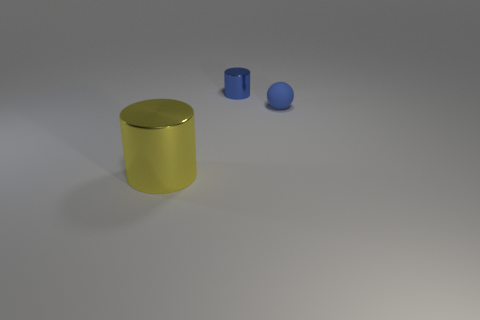Does the tiny blue thing behind the blue sphere have the same material as the cylinder in front of the tiny blue matte ball?
Provide a short and direct response. Yes. The yellow shiny thing has what size?
Keep it short and to the point. Large. There is a yellow object that is the same shape as the blue shiny thing; what size is it?
Your answer should be very brief. Large. What number of shiny objects are in front of the tiny blue cylinder?
Make the answer very short. 1. There is a object left of the metal cylinder behind the large shiny cylinder; what color is it?
Offer a very short reply. Yellow. Is there anything else that has the same shape as the small blue matte thing?
Make the answer very short. No. Are there an equal number of things right of the tiny blue cylinder and small matte objects on the right side of the yellow thing?
Offer a terse response. Yes. How many balls are large purple matte objects or big yellow things?
Offer a terse response. 0. What number of other objects are there of the same material as the small sphere?
Your answer should be compact. 0. The metal object on the right side of the big shiny cylinder has what shape?
Keep it short and to the point. Cylinder. 